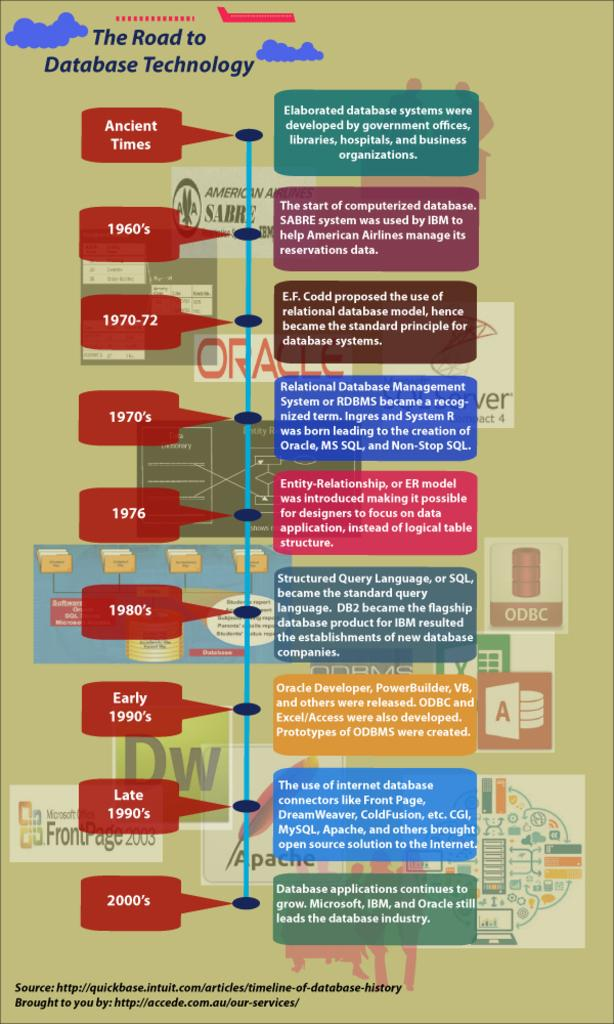<image>
Provide a brief description of the given image. A colorful chart is titled the road to database technology. 